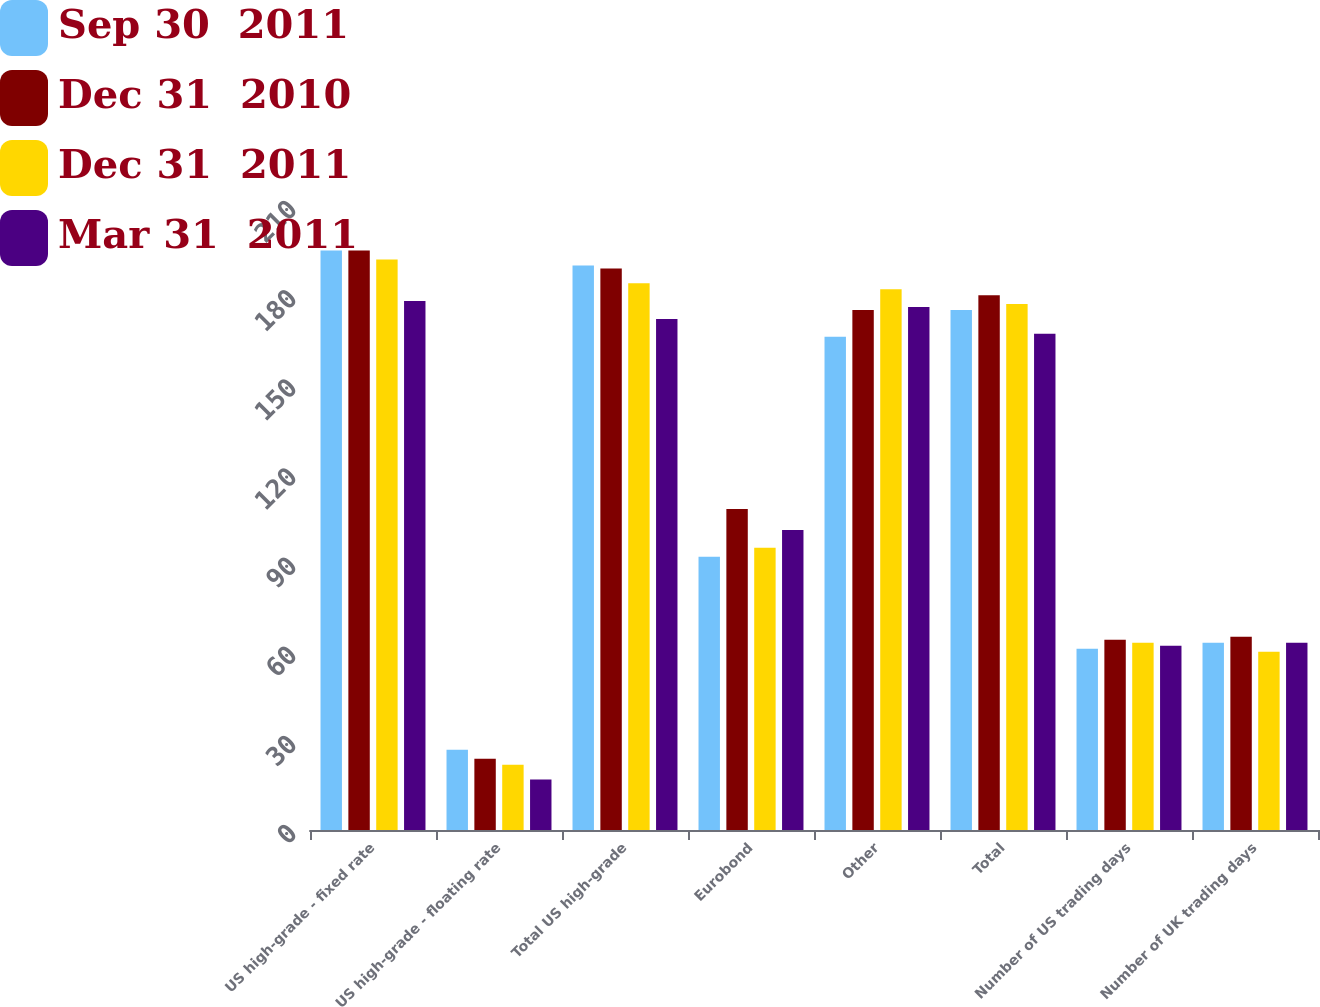Convert chart. <chart><loc_0><loc_0><loc_500><loc_500><stacked_bar_chart><ecel><fcel>US high-grade - fixed rate<fcel>US high-grade - floating rate<fcel>Total US high-grade<fcel>Eurobond<fcel>Other<fcel>Total<fcel>Number of US trading days<fcel>Number of UK trading days<nl><fcel>Sep 30  2011<fcel>195<fcel>27<fcel>190<fcel>92<fcel>166<fcel>175<fcel>61<fcel>63<nl><fcel>Dec 31  2010<fcel>195<fcel>24<fcel>189<fcel>108<fcel>175<fcel>180<fcel>64<fcel>65<nl><fcel>Dec 31  2011<fcel>192<fcel>22<fcel>184<fcel>95<fcel>182<fcel>177<fcel>63<fcel>60<nl><fcel>Mar 31  2011<fcel>178<fcel>17<fcel>172<fcel>101<fcel>176<fcel>167<fcel>62<fcel>63<nl></chart> 